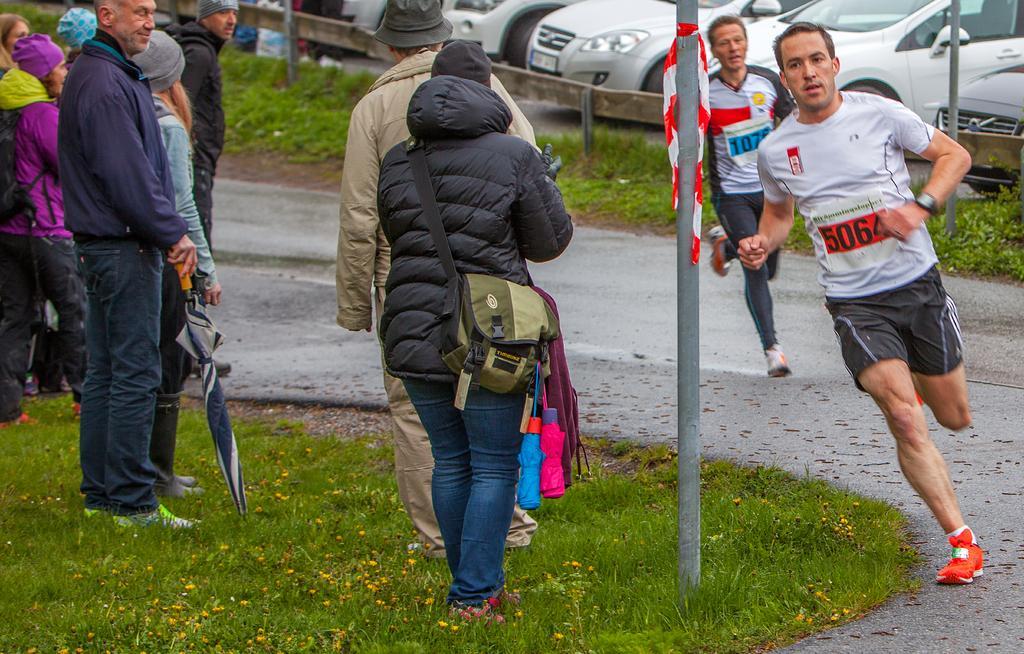Please provide a concise description of this image. This image is clicked on the road. To the right there is the road. There are two men running on the road. Beside the road there's grass on the ground. There are people standing on the ground. Beside them there is a pole on the ground. In the background there are cars parked on the road. 